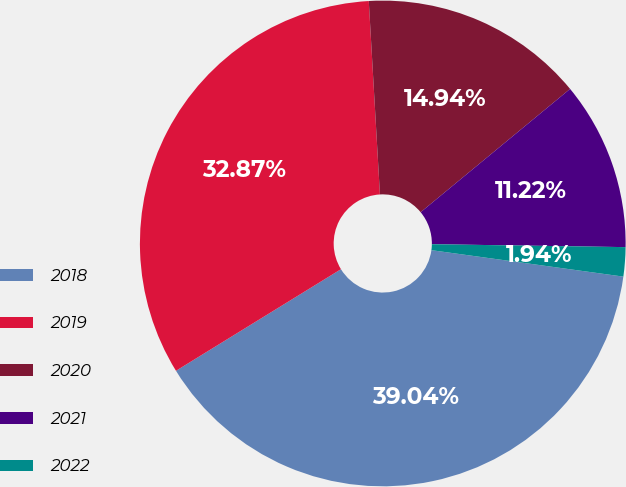Convert chart. <chart><loc_0><loc_0><loc_500><loc_500><pie_chart><fcel>2018<fcel>2019<fcel>2020<fcel>2021<fcel>2022<nl><fcel>39.04%<fcel>32.87%<fcel>14.94%<fcel>11.22%<fcel>1.94%<nl></chart> 